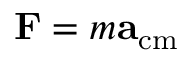<formula> <loc_0><loc_0><loc_500><loc_500>F = m a _ { c m }</formula> 